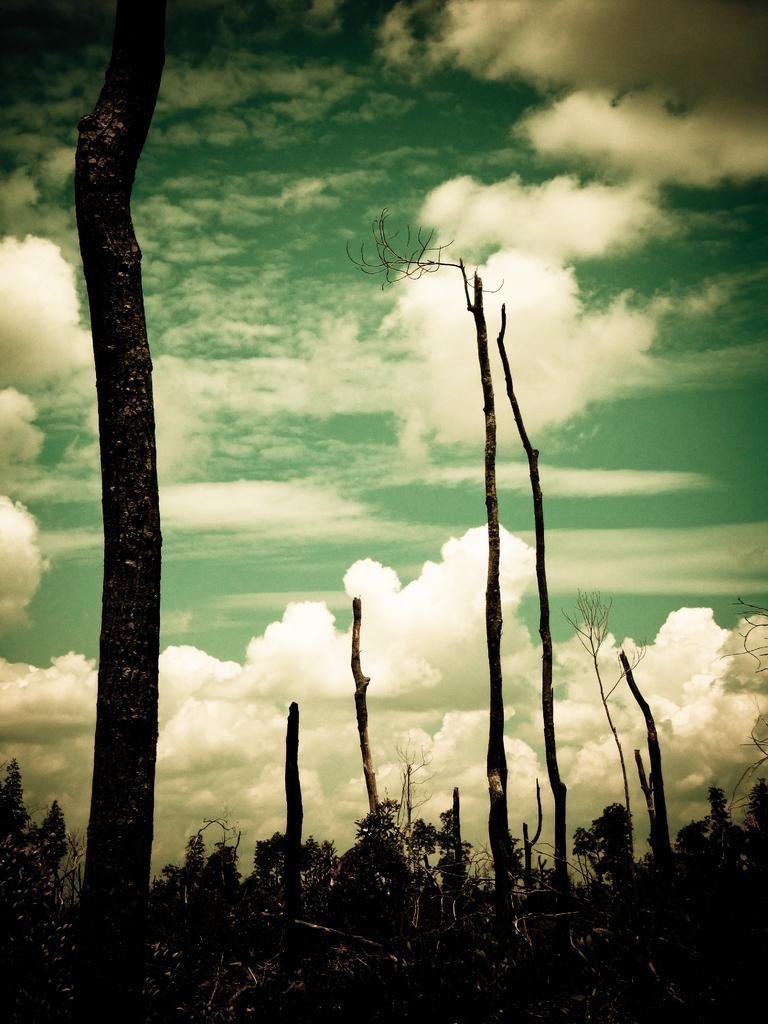In one or two sentences, can you explain what this image depicts? There are trees at the bottom of this image, and there is a cloudy sky in the background. 